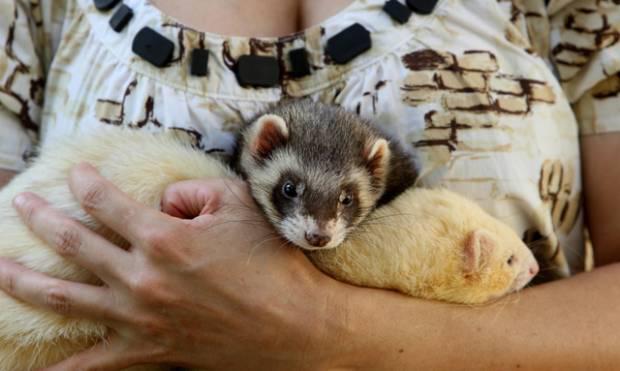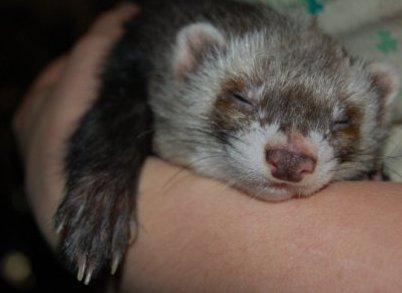The first image is the image on the left, the second image is the image on the right. Given the left and right images, does the statement "One or more ferrets is being held by a human in each photo." hold true? Answer yes or no. Yes. The first image is the image on the left, the second image is the image on the right. For the images shown, is this caption "The left image contains a ferret resting its head on another ferrets neck." true? Answer yes or no. Yes. 